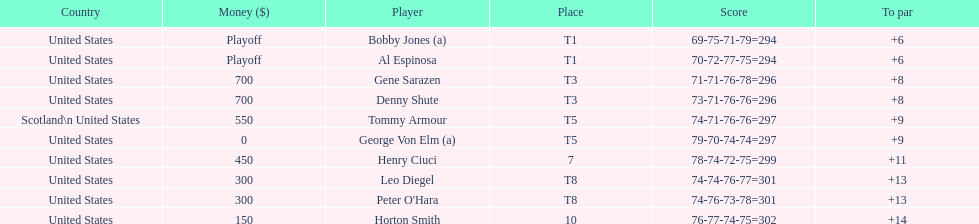Which two players tied for first place? Bobby Jones (a), Al Espinosa. 